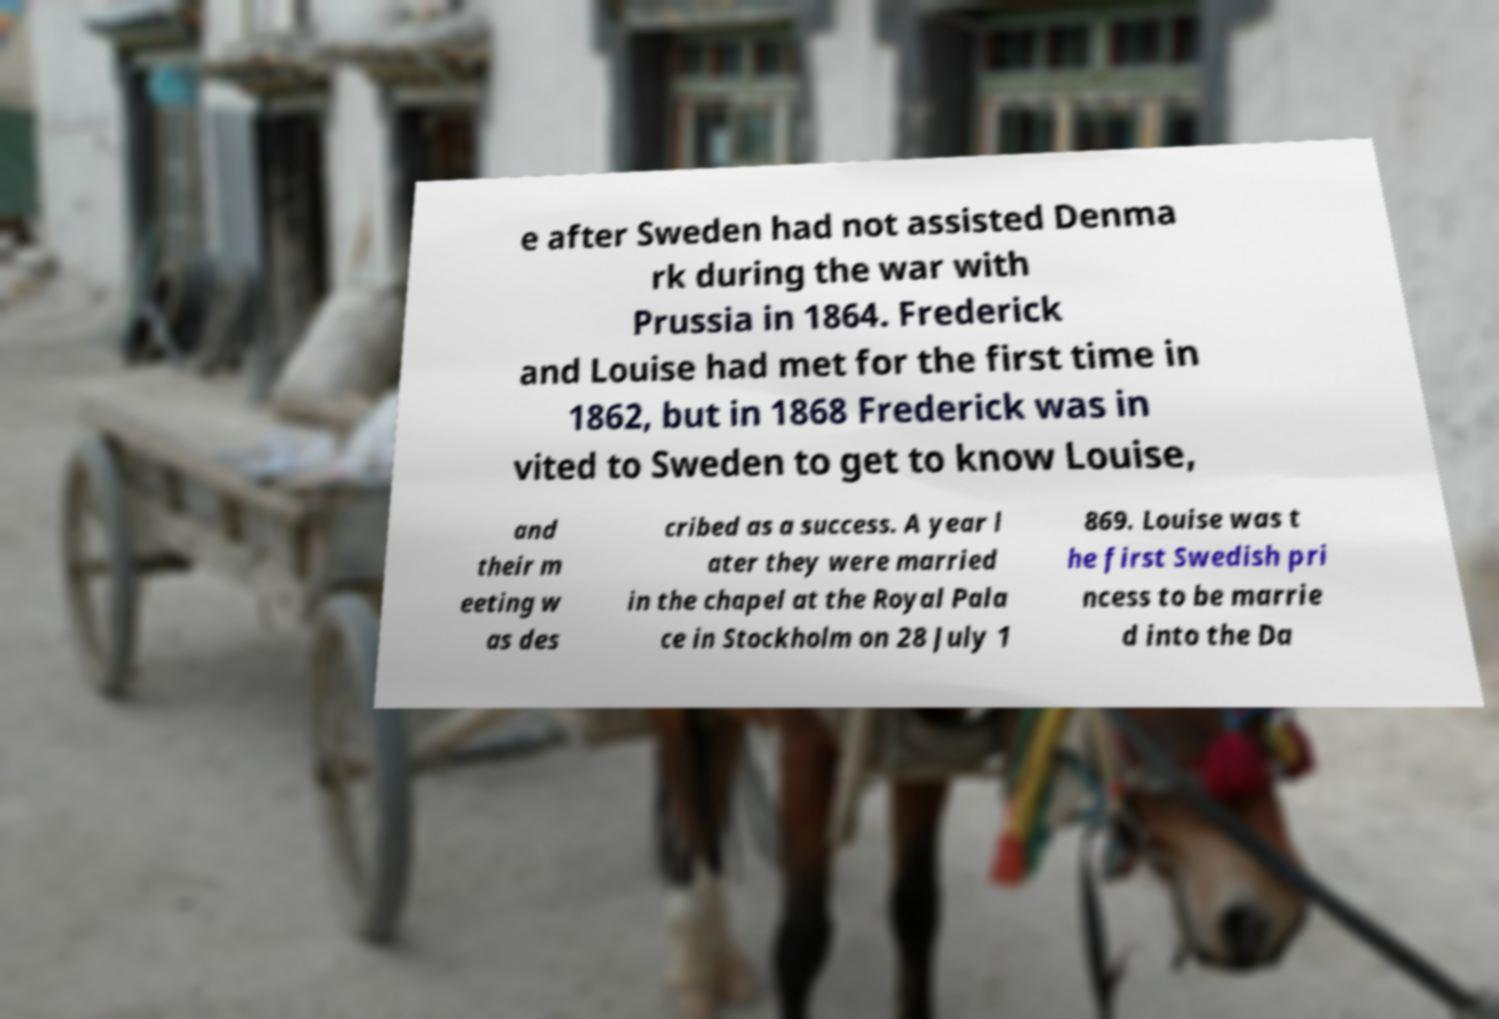I need the written content from this picture converted into text. Can you do that? e after Sweden had not assisted Denma rk during the war with Prussia in 1864. Frederick and Louise had met for the first time in 1862, but in 1868 Frederick was in vited to Sweden to get to know Louise, and their m eeting w as des cribed as a success. A year l ater they were married in the chapel at the Royal Pala ce in Stockholm on 28 July 1 869. Louise was t he first Swedish pri ncess to be marrie d into the Da 